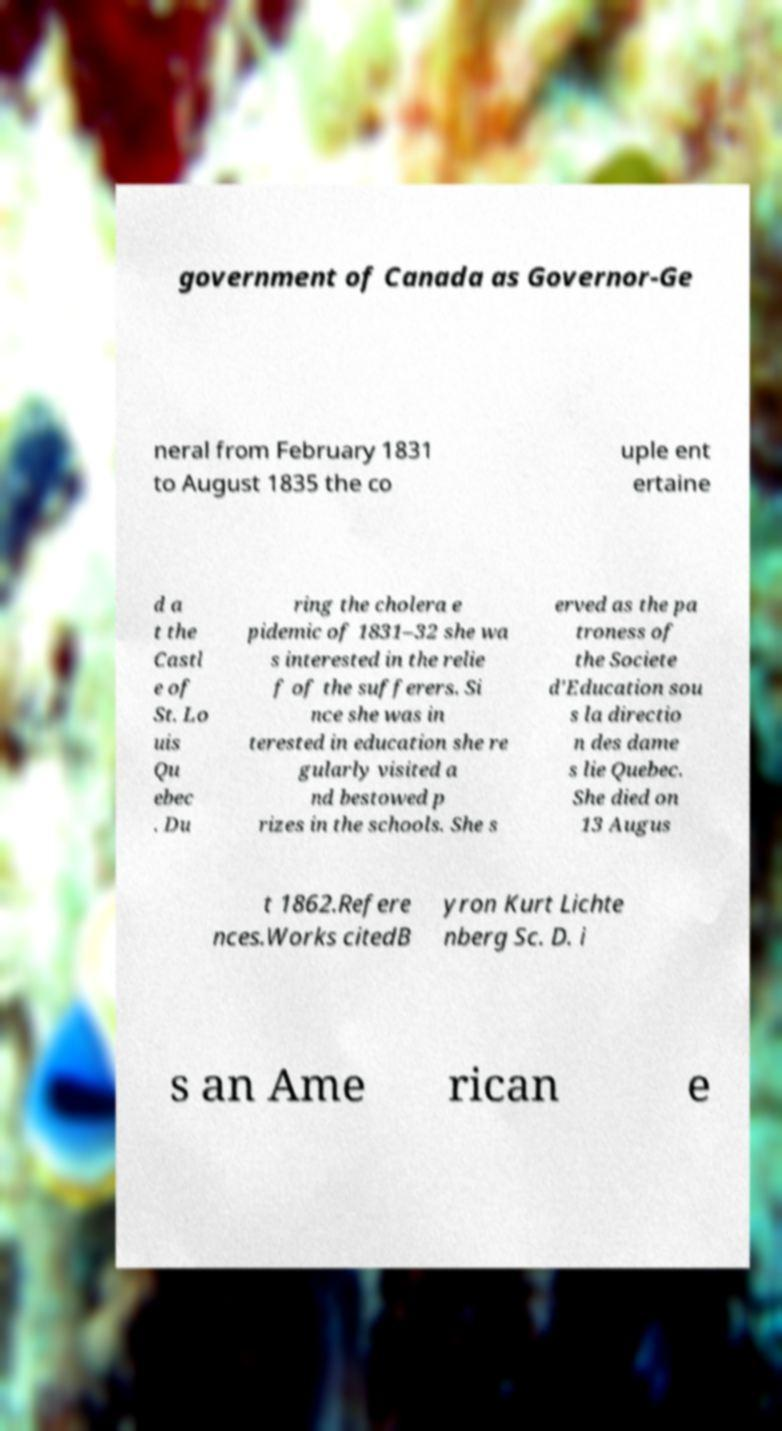Can you accurately transcribe the text from the provided image for me? government of Canada as Governor-Ge neral from February 1831 to August 1835 the co uple ent ertaine d a t the Castl e of St. Lo uis Qu ebec . Du ring the cholera e pidemic of 1831–32 she wa s interested in the relie f of the sufferers. Si nce she was in terested in education she re gularly visited a nd bestowed p rizes in the schools. She s erved as the pa troness of the Societe d'Education sou s la directio n des dame s lie Quebec. She died on 13 Augus t 1862.Refere nces.Works citedB yron Kurt Lichte nberg Sc. D. i s an Ame rican e 